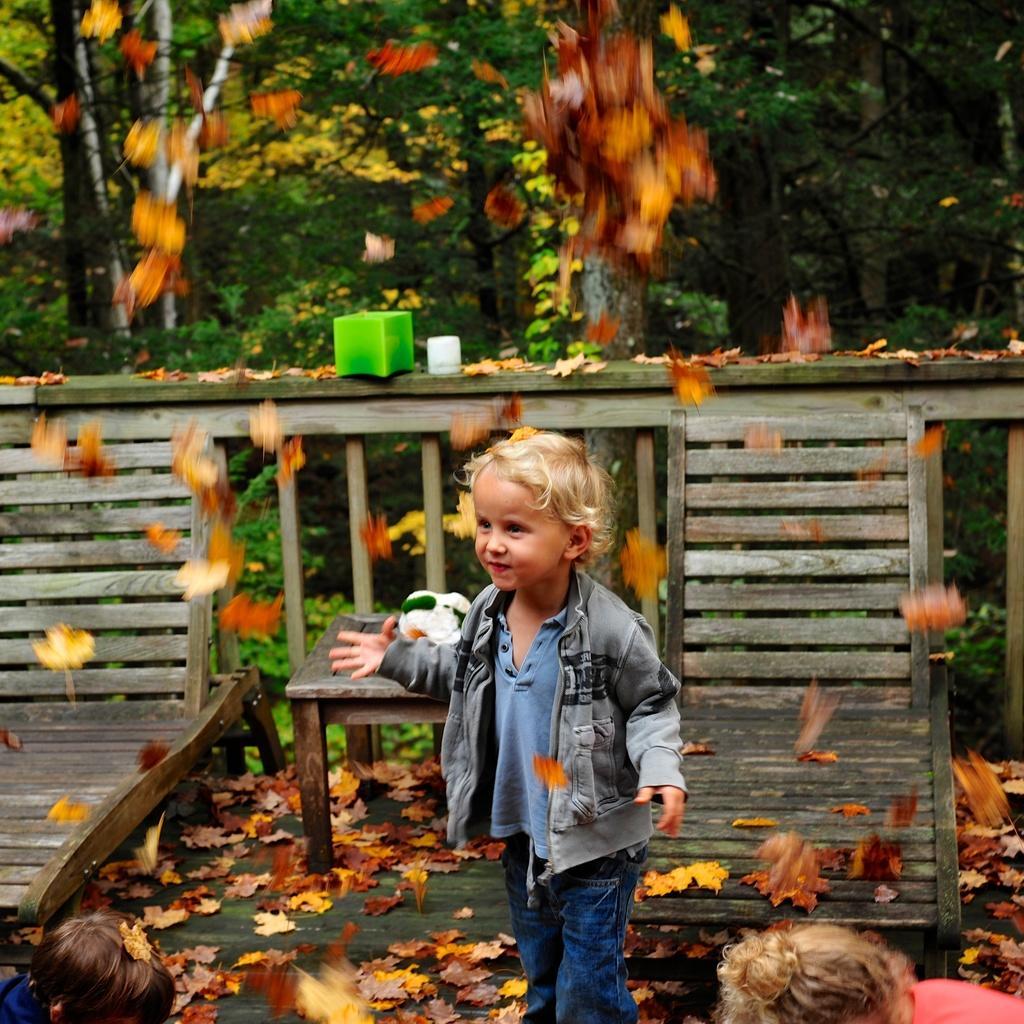Describe this image in one or two sentences. In this picture I can see a kid on the wooden floor. I can see a kid on the left side. I can see a kid on the right side. I can see wooden deck chairs. I can see wooden fence. I can see the table. I can see trees in the background. 